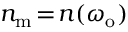Convert formula to latex. <formula><loc_0><loc_0><loc_500><loc_500>n _ { m } \, = \, n ( \omega _ { o } )</formula> 